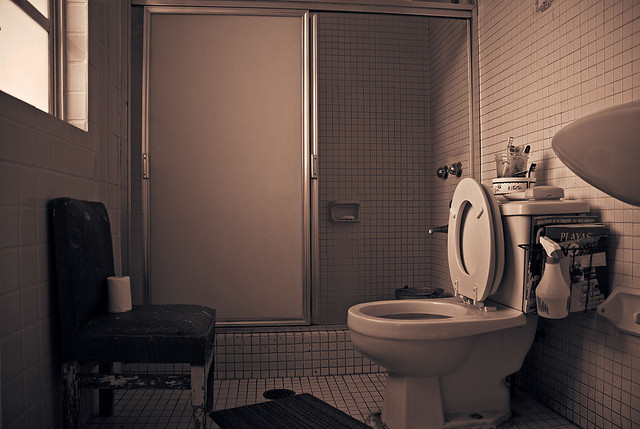<image>Is this a photograph or is it an architectural drawing? I don't know if this is a photograph or an architectural drawing. Where is the tissue box? It is unanswerable where the tissue box is located. It might be on the chair or on the toilet. Is this a photograph or is it an architectural drawing? I am not sure if this is a photograph or an architectural drawing. However, it seems to be a photograph. Where is the tissue box? It is unclear where the tissue box is located. It can be seen on the chair, on the toilet, or on the toilet lid. 